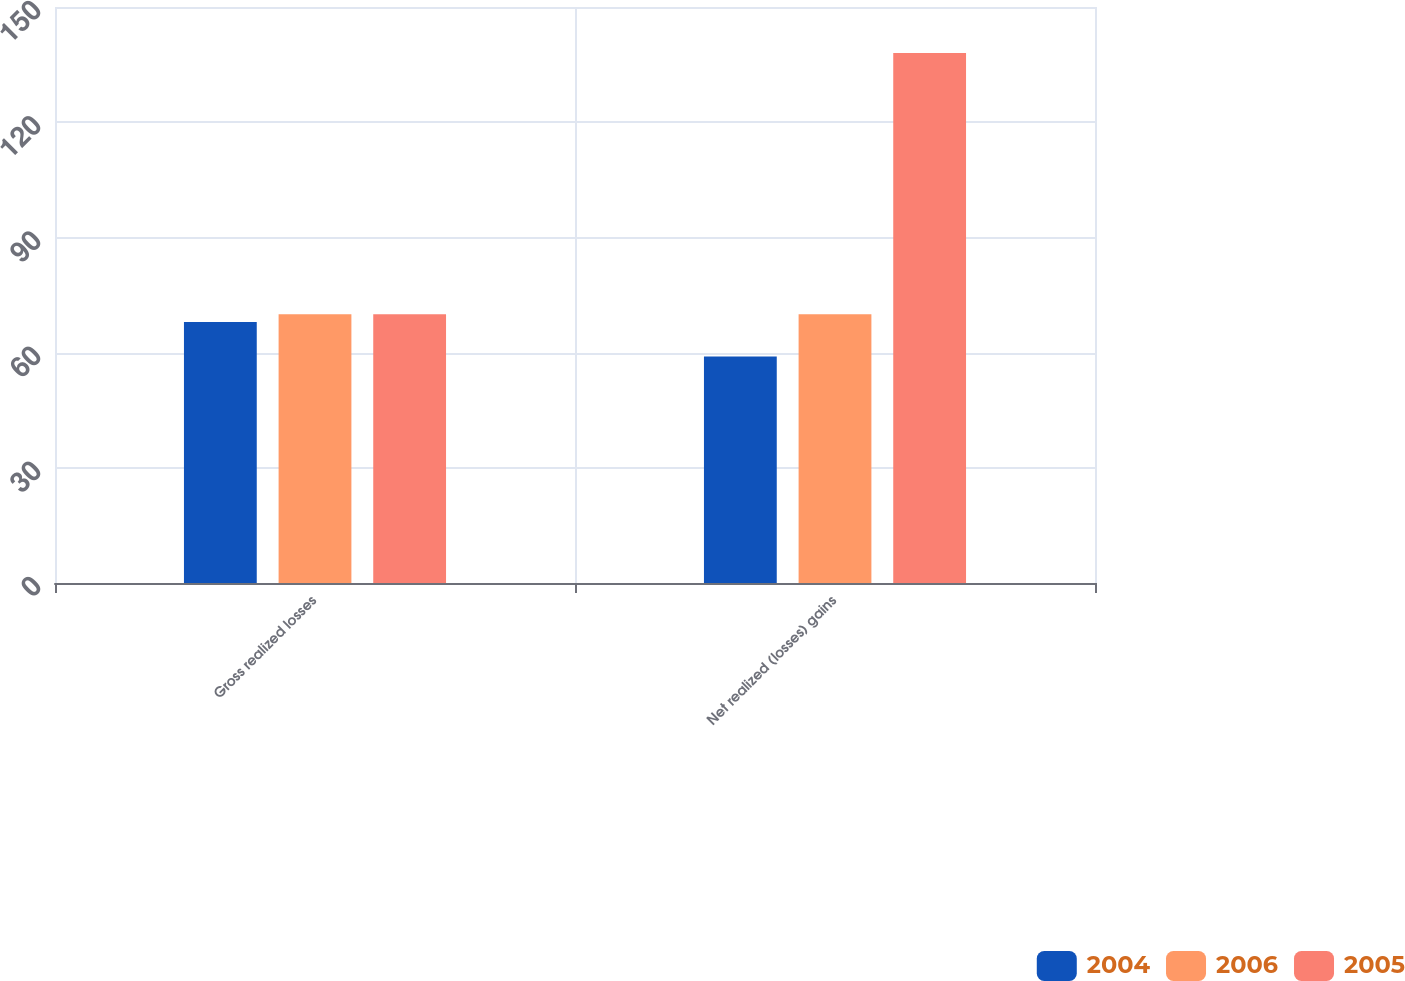Convert chart to OTSL. <chart><loc_0><loc_0><loc_500><loc_500><stacked_bar_chart><ecel><fcel>Gross realized losses<fcel>Net realized (losses) gains<nl><fcel>2004<fcel>68<fcel>59<nl><fcel>2006<fcel>70<fcel>70<nl><fcel>2005<fcel>70<fcel>138<nl></chart> 